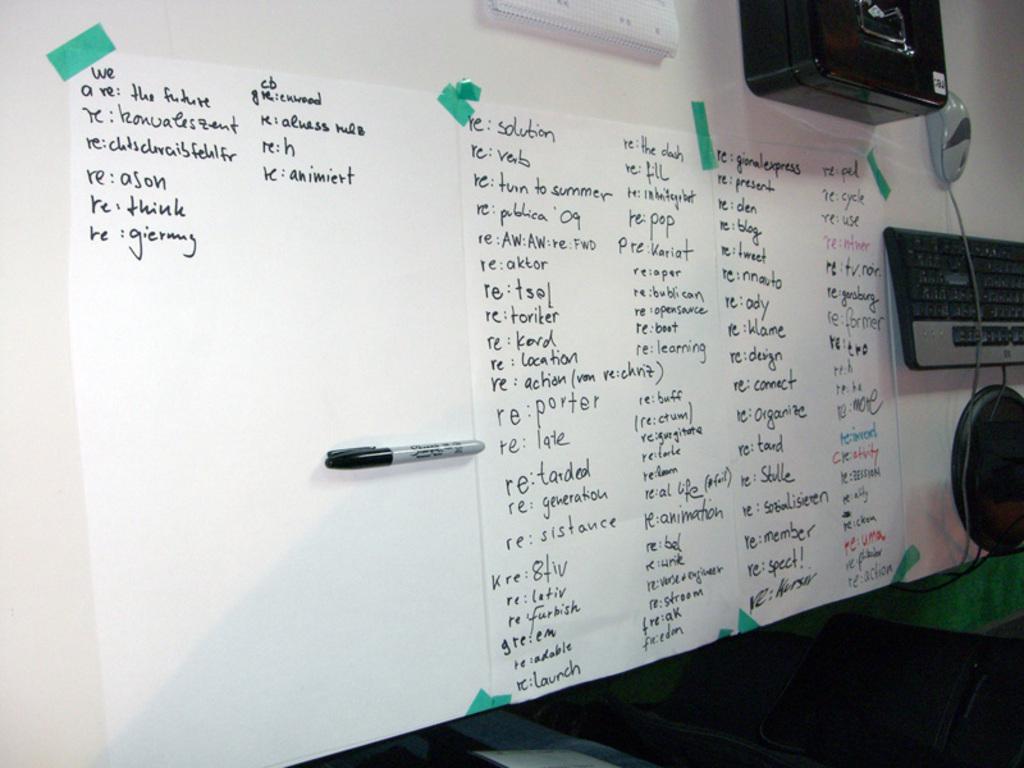We are what, according to the upper left corner?
Offer a terse response. The future. What is the first word of the third column?
Your answer should be very brief. Solution. 